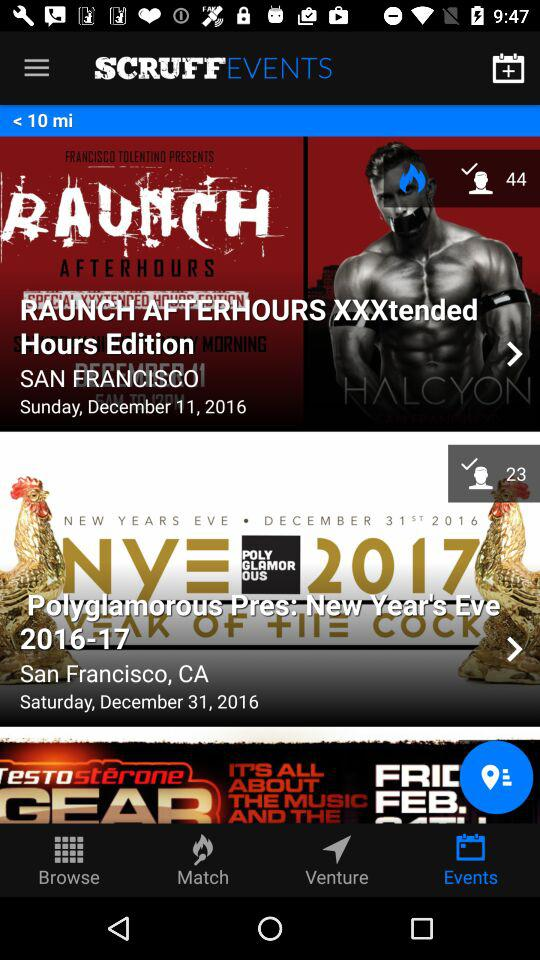What is the location of "RAUNCH AFTERHOURS XXXtended Hours Edition"? The location is San Francisco. 